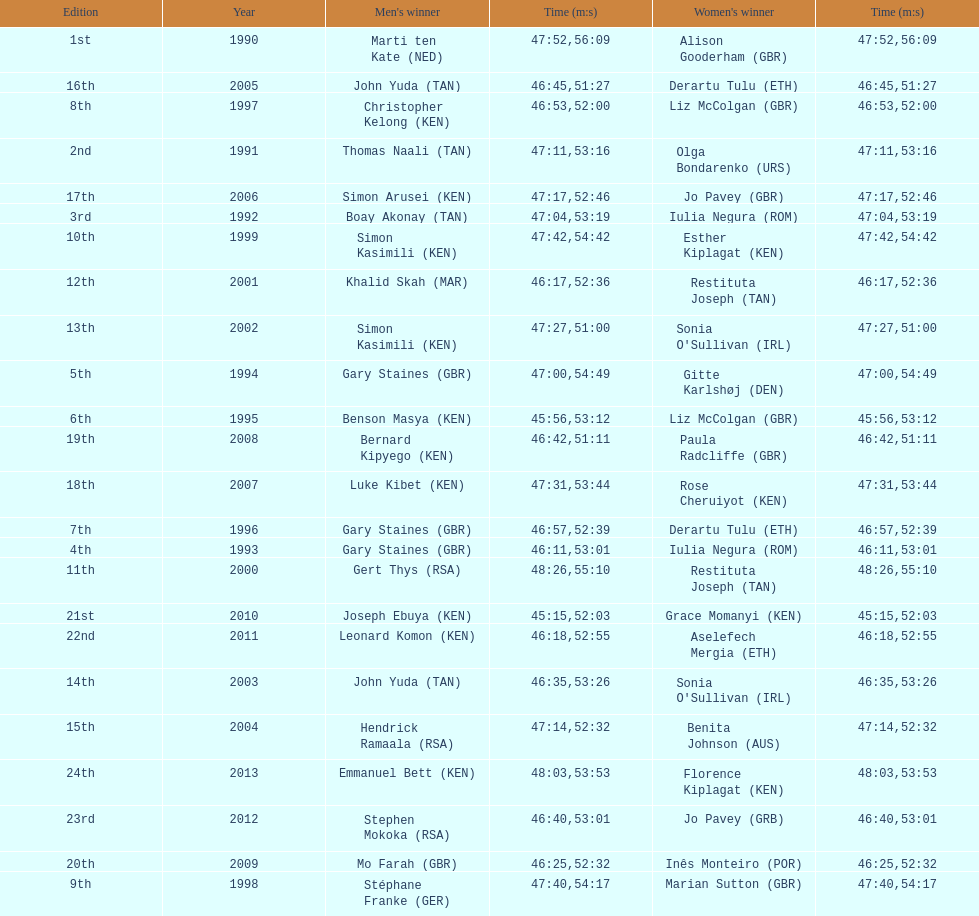Home many times did a single country win both the men's and women's bupa great south run? 4. 